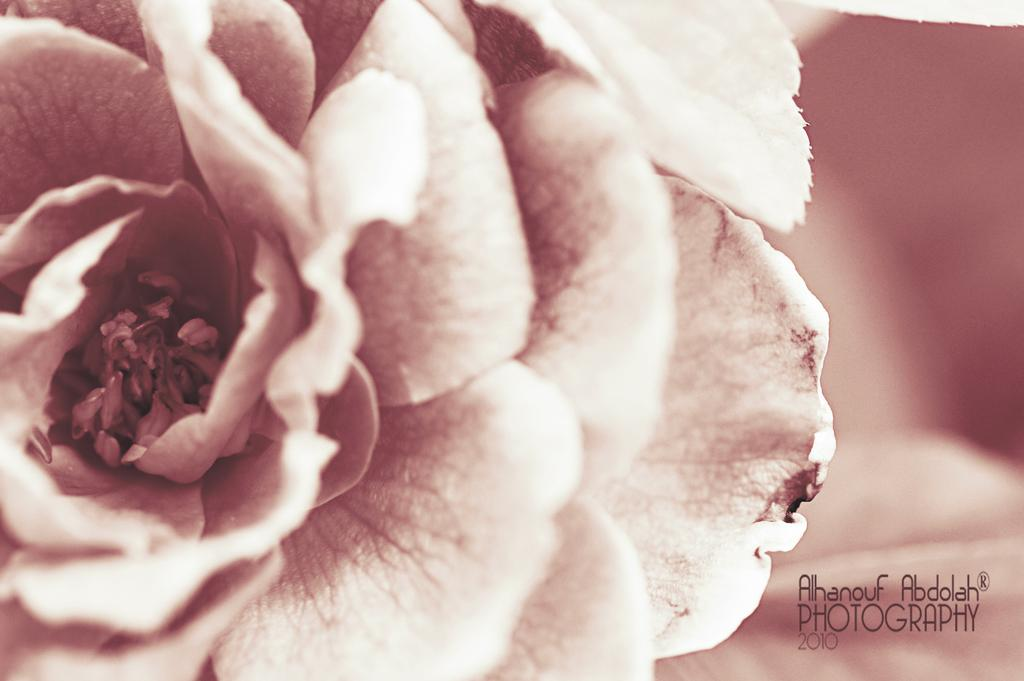What is the main subject of the image? There is a flower in the image. Can you describe the colors of the flower? The flower has peach and cream colors. Is there any text or writing visible in the image? Yes, there is text or writing visible in the image. What type of furniture is visible in the image? There is no furniture present in the image; it features a flower with peach and cream colors and text or writing. How does the letter fit into the image? There is no letter present in the image; it only contains a flower and text or writing. 